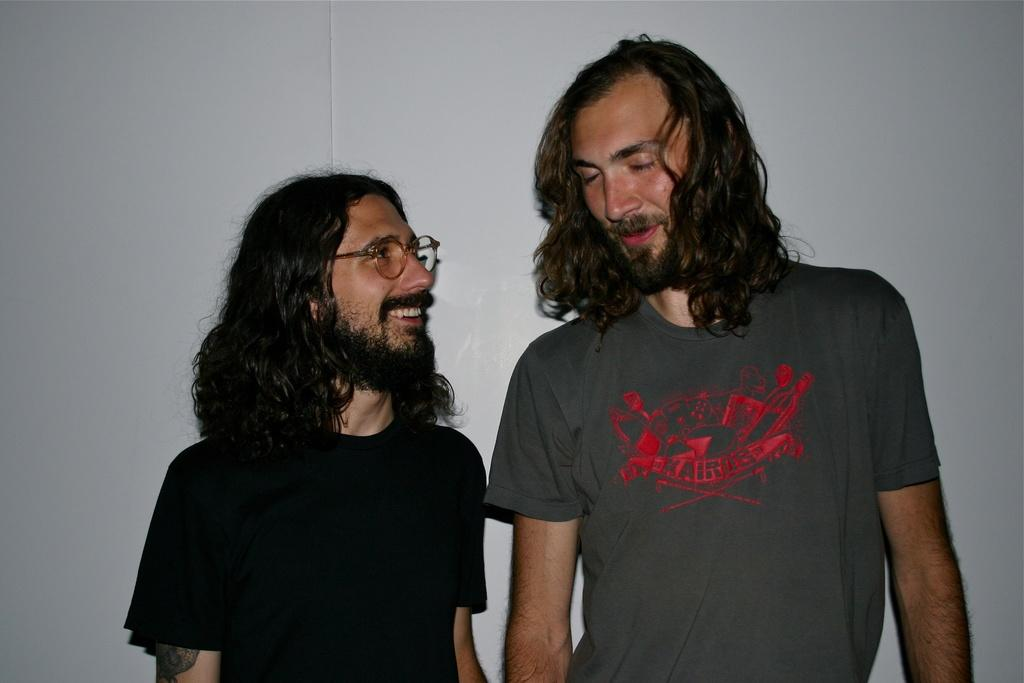How many people are in the image? There are two persons in the image. What are the persons wearing? Both persons are wearing T-shirts. Can you describe the appearance of the persons' hair? Both persons have long hair. What can be seen in the background of the image? There is a white wall in the background of the image. How many cats are sitting on the memory in the image? There are no cats or memories present in the image. What type of mine is visible in the image? There is no mine present in the image. 